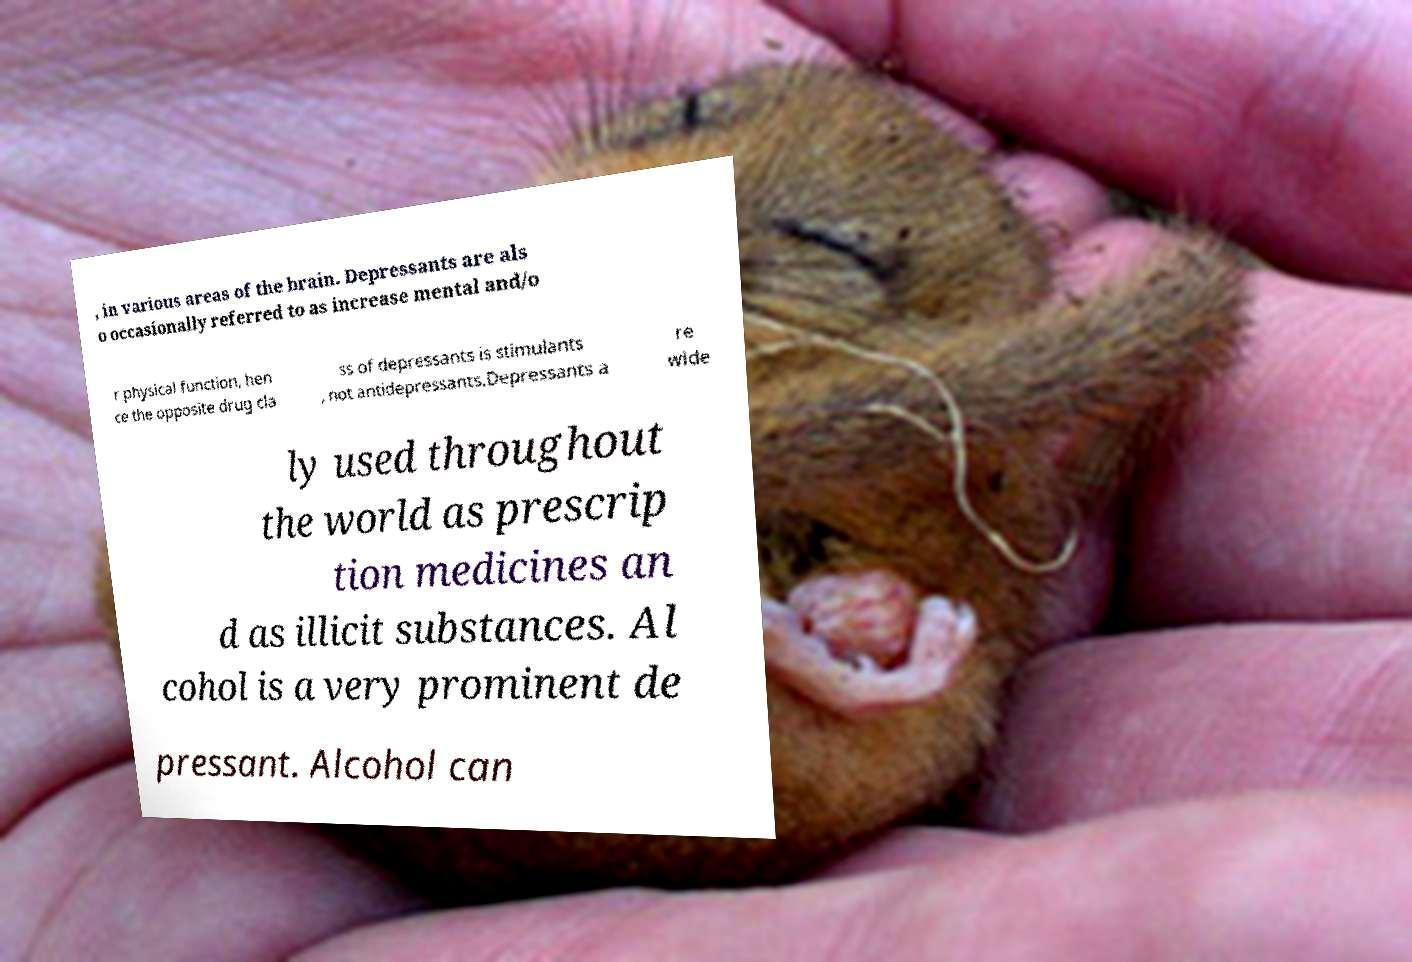I need the written content from this picture converted into text. Can you do that? , in various areas of the brain. Depressants are als o occasionally referred to as increase mental and/o r physical function, hen ce the opposite drug cla ss of depressants is stimulants , not antidepressants.Depressants a re wide ly used throughout the world as prescrip tion medicines an d as illicit substances. Al cohol is a very prominent de pressant. Alcohol can 